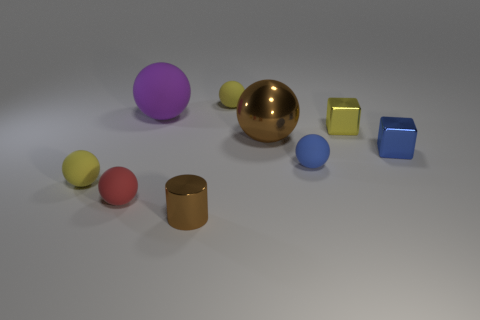Subtract all red spheres. How many spheres are left? 5 Subtract all large brown metal spheres. How many spheres are left? 5 Subtract all gray balls. Subtract all green blocks. How many balls are left? 6 Add 1 large matte things. How many objects exist? 10 Subtract all cylinders. How many objects are left? 8 Subtract all small brown matte things. Subtract all tiny blue cubes. How many objects are left? 8 Add 6 large brown shiny spheres. How many large brown shiny spheres are left? 7 Add 5 big brown shiny objects. How many big brown shiny objects exist? 6 Subtract 1 red balls. How many objects are left? 8 